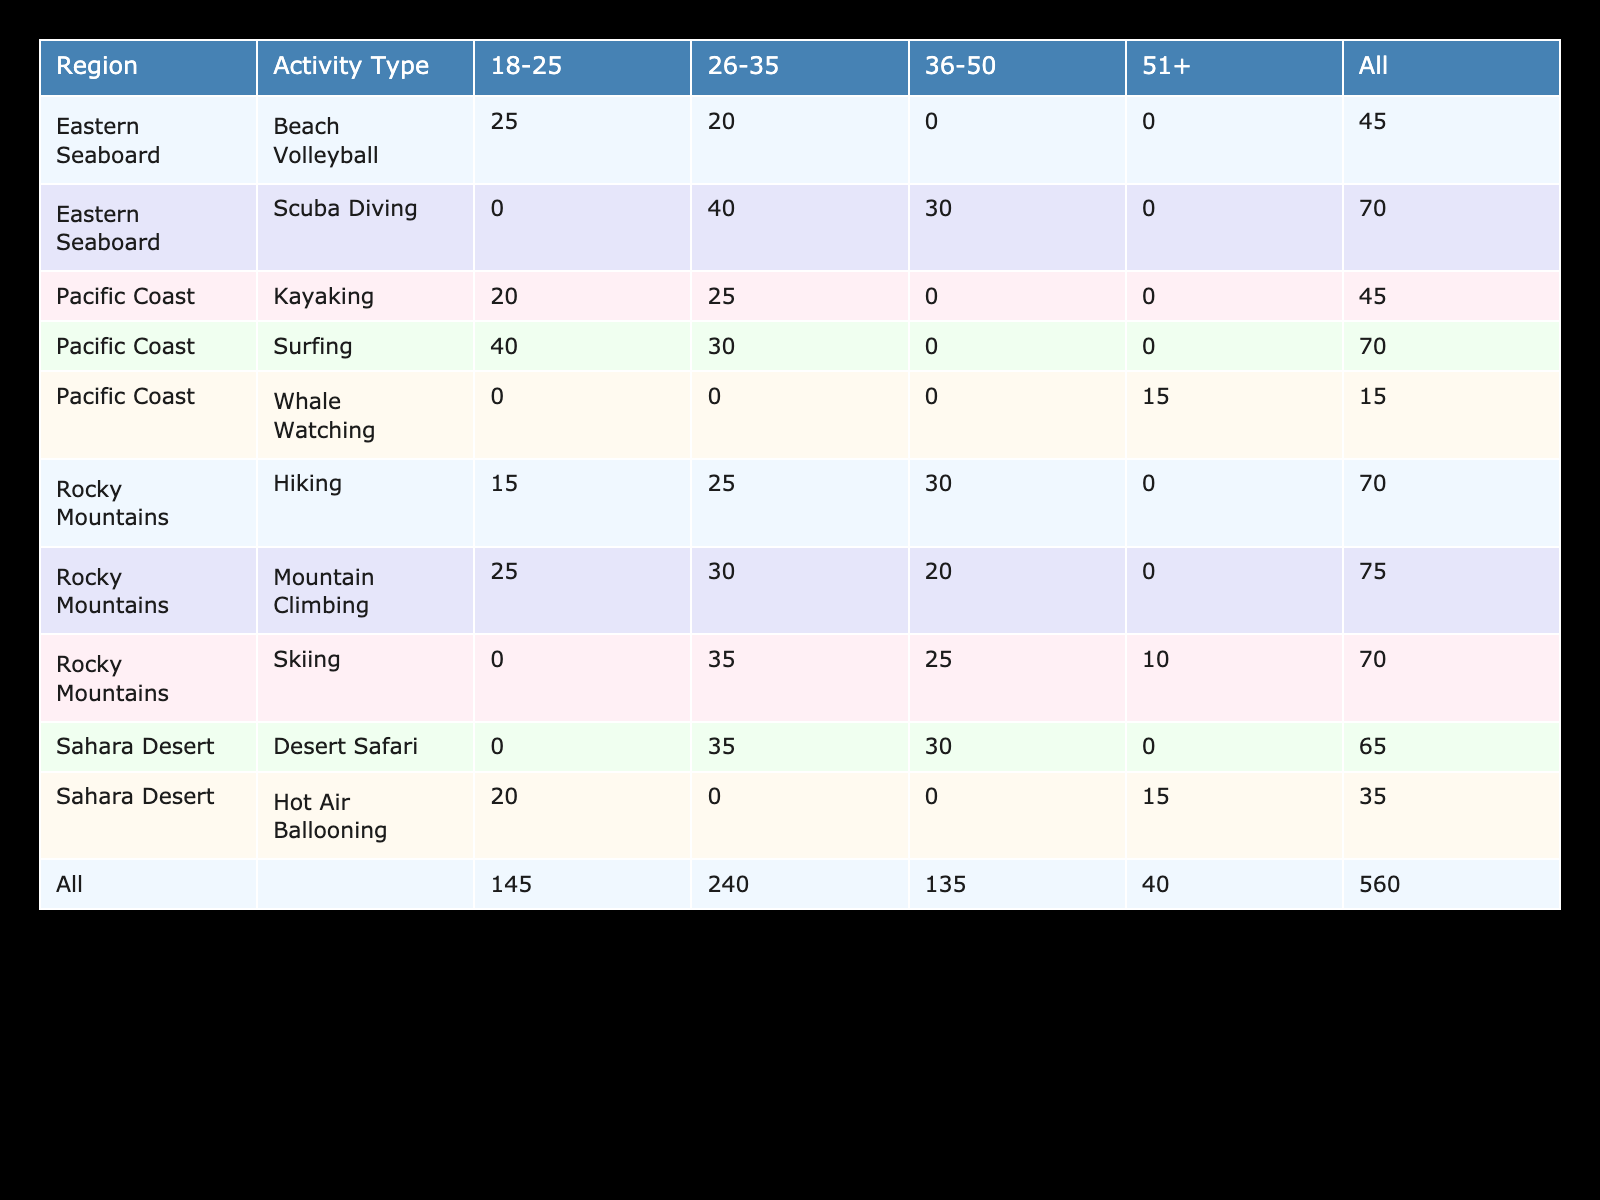What percentage of the Rocky Mountains' visitors engage in Mountain Climbing in the 18-25 age group? Referring to the table, the percentage of visitors in the Rocky Mountains who participate in Mountain Climbing and belong to the 18-25 age group is directly provided as 25%.
Answer: 25% Which activity has the highest percentage participation among the 26-35 age group in the Pacific Coast? Looking through the Pacific Coast section for the 26-35 age group, Surfing at 30% has the highest value compared to Kayaking at 25%.
Answer: Surfing Is it true that more people aged 51 and above prefer Whale Watching than Desert Safari? In the table, we see that Whale Watching has a percentage of 15% for the 51+ age group, while Desert Safari has 0% for that age group as it does not appear in this category. Therefore, the statement is true.
Answer: Yes What is the total percentage of Rocky Mountains visitors aged 36-50 who engage in any activity? We sum up all the percentages for the 36-50 age group in the Rocky Mountains: Mountain Climbing (20%), Hiking (30%), Skiing (25%), which gives 20 + 30 + 25 = 75%.
Answer: 75% Among all the regions for the age group 18-25, which activity type has the highest overall participation? Calculating the total for 18-25 across regions: Rocky Mountains (Mountain Climbing 25% + Hiking 15%), Pacific Coast (Surfing 40% + Kayaking 20%), and Eastern Seaboard (Beach Volleyball 25%). The highest is Surfing at 40%.
Answer: Surfing What percentage of Eastern Seaboard visitors aged 26-35 participate in Scuba Diving compared to those in Beach Volleyball? The percentage of visitors aged 26-35 engaging in Scuba Diving is 40% and Beach Volleyball is 20%. Therefore, Scuba Diving has twice the participation rate compared to Beach Volleyball.
Answer: 40% vs 20% 